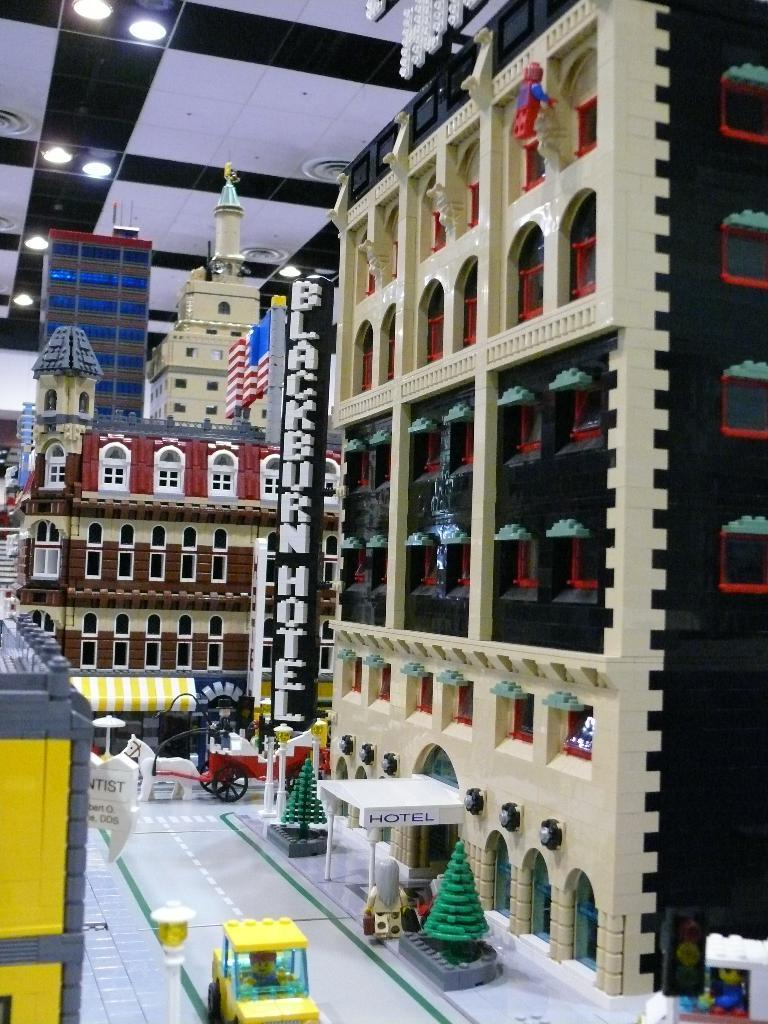What type of toy is present in the image? There is Lego in the image. What kind of structures are made from the Lego in the image? There are toy buildings in the image. What other types of toys can be seen in the image? There are toy vehicles in the image. What type of natural elements are present in the image? There are trees in the image. What feature can be seen on the roof of the toy buildings? There are lights on the roof in the image. What type of flag is flying on top of the Lego building in the image? There is no flag present in the image; it only features Lego, toy buildings, toy vehicles, trees, and lights on the roof. 